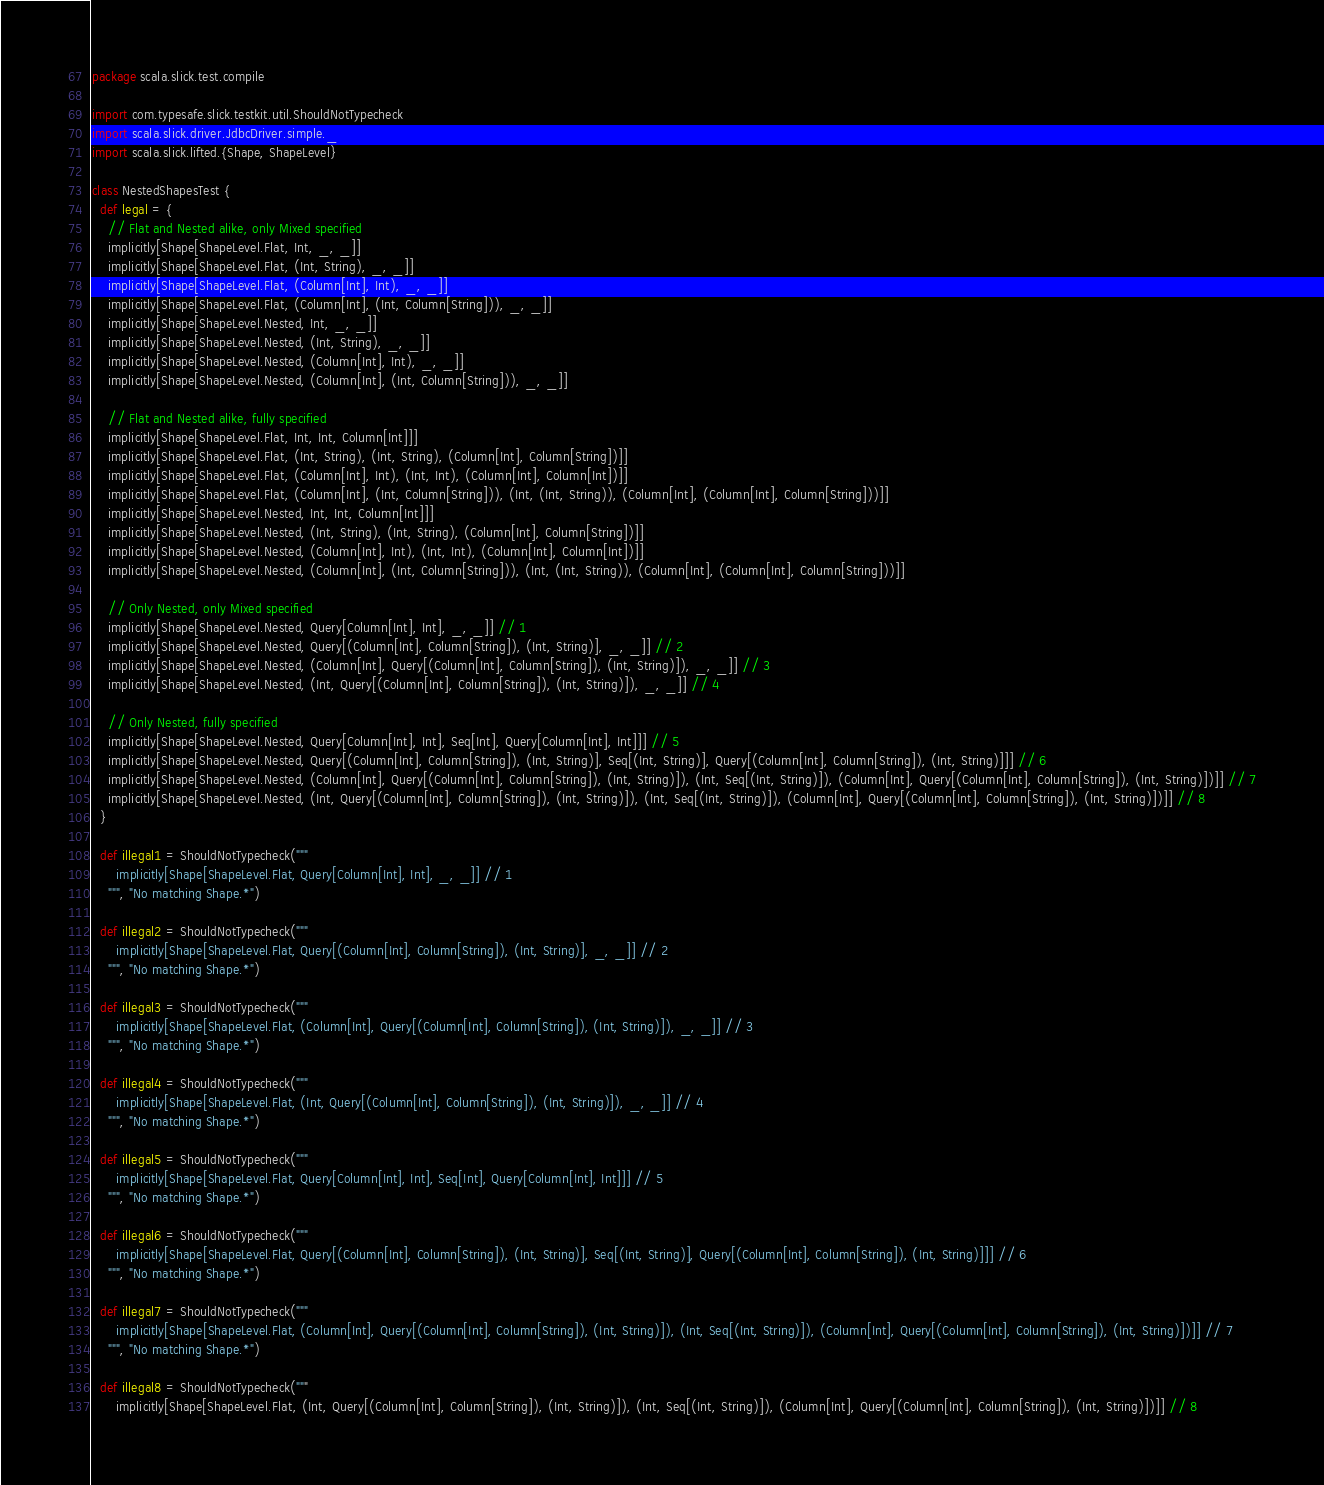<code> <loc_0><loc_0><loc_500><loc_500><_Scala_>package scala.slick.test.compile

import com.typesafe.slick.testkit.util.ShouldNotTypecheck
import scala.slick.driver.JdbcDriver.simple._
import scala.slick.lifted.{Shape, ShapeLevel}

class NestedShapesTest {
  def legal = {
    // Flat and Nested alike, only Mixed specified
    implicitly[Shape[ShapeLevel.Flat, Int, _, _]]
    implicitly[Shape[ShapeLevel.Flat, (Int, String), _, _]]
    implicitly[Shape[ShapeLevel.Flat, (Column[Int], Int), _, _]]
    implicitly[Shape[ShapeLevel.Flat, (Column[Int], (Int, Column[String])), _, _]]
    implicitly[Shape[ShapeLevel.Nested, Int, _, _]]
    implicitly[Shape[ShapeLevel.Nested, (Int, String), _, _]]
    implicitly[Shape[ShapeLevel.Nested, (Column[Int], Int), _, _]]
    implicitly[Shape[ShapeLevel.Nested, (Column[Int], (Int, Column[String])), _, _]]

    // Flat and Nested alike, fully specified
    implicitly[Shape[ShapeLevel.Flat, Int, Int, Column[Int]]]
    implicitly[Shape[ShapeLevel.Flat, (Int, String), (Int, String), (Column[Int], Column[String])]]
    implicitly[Shape[ShapeLevel.Flat, (Column[Int], Int), (Int, Int), (Column[Int], Column[Int])]]
    implicitly[Shape[ShapeLevel.Flat, (Column[Int], (Int, Column[String])), (Int, (Int, String)), (Column[Int], (Column[Int], Column[String]))]]
    implicitly[Shape[ShapeLevel.Nested, Int, Int, Column[Int]]]
    implicitly[Shape[ShapeLevel.Nested, (Int, String), (Int, String), (Column[Int], Column[String])]]
    implicitly[Shape[ShapeLevel.Nested, (Column[Int], Int), (Int, Int), (Column[Int], Column[Int])]]
    implicitly[Shape[ShapeLevel.Nested, (Column[Int], (Int, Column[String])), (Int, (Int, String)), (Column[Int], (Column[Int], Column[String]))]]

    // Only Nested, only Mixed specified
    implicitly[Shape[ShapeLevel.Nested, Query[Column[Int], Int], _, _]] // 1
    implicitly[Shape[ShapeLevel.Nested, Query[(Column[Int], Column[String]), (Int, String)], _, _]] // 2
    implicitly[Shape[ShapeLevel.Nested, (Column[Int], Query[(Column[Int], Column[String]), (Int, String)]), _, _]] // 3
    implicitly[Shape[ShapeLevel.Nested, (Int, Query[(Column[Int], Column[String]), (Int, String)]), _, _]] // 4

    // Only Nested, fully specified
    implicitly[Shape[ShapeLevel.Nested, Query[Column[Int], Int], Seq[Int], Query[Column[Int], Int]]] // 5
    implicitly[Shape[ShapeLevel.Nested, Query[(Column[Int], Column[String]), (Int, String)], Seq[(Int, String)], Query[(Column[Int], Column[String]), (Int, String)]]] // 6
    implicitly[Shape[ShapeLevel.Nested, (Column[Int], Query[(Column[Int], Column[String]), (Int, String)]), (Int, Seq[(Int, String)]), (Column[Int], Query[(Column[Int], Column[String]), (Int, String)])]] // 7
    implicitly[Shape[ShapeLevel.Nested, (Int, Query[(Column[Int], Column[String]), (Int, String)]), (Int, Seq[(Int, String)]), (Column[Int], Query[(Column[Int], Column[String]), (Int, String)])]] // 8
  }

  def illegal1 = ShouldNotTypecheck("""
      implicitly[Shape[ShapeLevel.Flat, Query[Column[Int], Int], _, _]] // 1
    """, "No matching Shape.*")

  def illegal2 = ShouldNotTypecheck("""
      implicitly[Shape[ShapeLevel.Flat, Query[(Column[Int], Column[String]), (Int, String)], _, _]] // 2
    """, "No matching Shape.*")

  def illegal3 = ShouldNotTypecheck("""
      implicitly[Shape[ShapeLevel.Flat, (Column[Int], Query[(Column[Int], Column[String]), (Int, String)]), _, _]] // 3
    """, "No matching Shape.*")

  def illegal4 = ShouldNotTypecheck("""
      implicitly[Shape[ShapeLevel.Flat, (Int, Query[(Column[Int], Column[String]), (Int, String)]), _, _]] // 4
    """, "No matching Shape.*")

  def illegal5 = ShouldNotTypecheck("""
      implicitly[Shape[ShapeLevel.Flat, Query[Column[Int], Int], Seq[Int], Query[Column[Int], Int]]] // 5
    """, "No matching Shape.*")

  def illegal6 = ShouldNotTypecheck("""
      implicitly[Shape[ShapeLevel.Flat, Query[(Column[Int], Column[String]), (Int, String)], Seq[(Int, String)], Query[(Column[Int], Column[String]), (Int, String)]]] // 6
    """, "No matching Shape.*")

  def illegal7 = ShouldNotTypecheck("""
      implicitly[Shape[ShapeLevel.Flat, (Column[Int], Query[(Column[Int], Column[String]), (Int, String)]), (Int, Seq[(Int, String)]), (Column[Int], Query[(Column[Int], Column[String]), (Int, String)])]] // 7
    """, "No matching Shape.*")

  def illegal8 = ShouldNotTypecheck("""
      implicitly[Shape[ShapeLevel.Flat, (Int, Query[(Column[Int], Column[String]), (Int, String)]), (Int, Seq[(Int, String)]), (Column[Int], Query[(Column[Int], Column[String]), (Int, String)])]] // 8</code> 